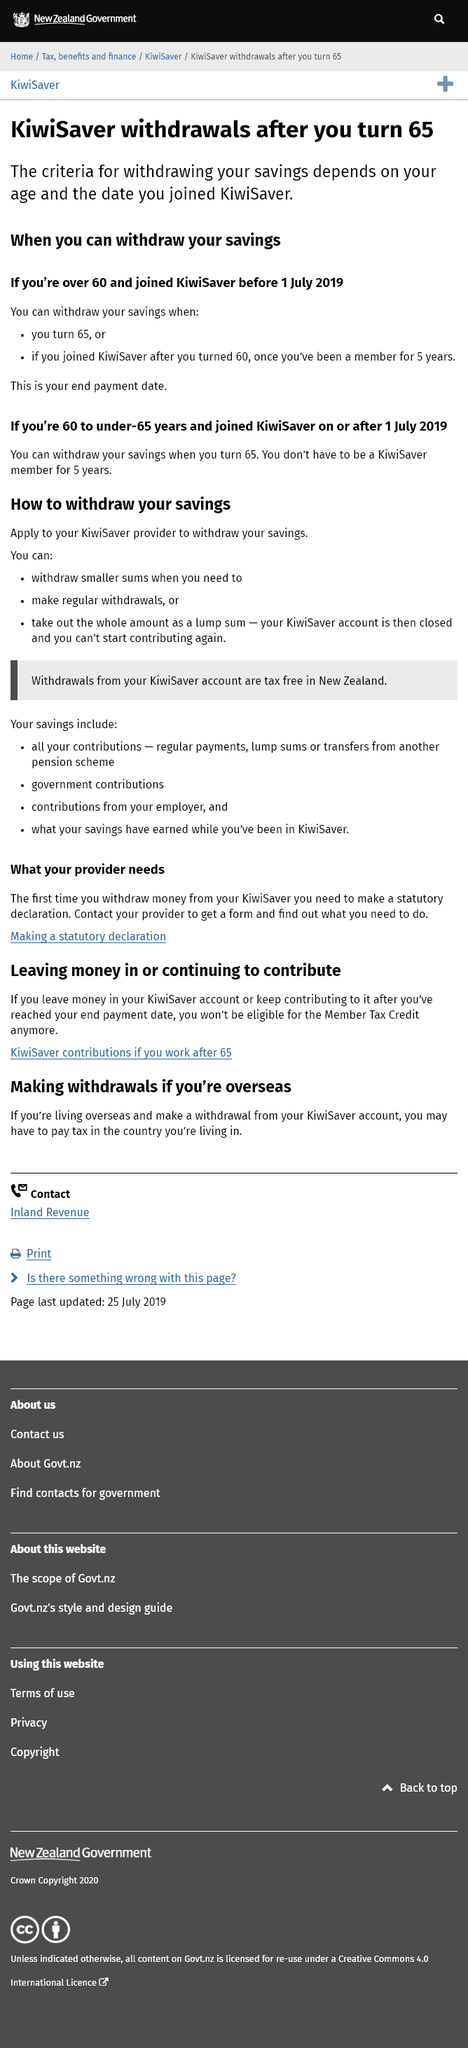Mention a couple of crucial points in this snapshot. Yes, you may have to pay tax in the country you're living in if you make a withdrawal from your KiwiSaver account while living overseas. Withdrawals from the KiwiSaver scheme in New Zealand are tax-free. The cut-off date of July 1, 2019, is stated as the date of significance for determining whether the Kiwisaver criteria apply to you, regardless of whether you opened the account before or after this date. To withdraw money from your KiwiSaver account for the first time, you must make a statutory declaration and provide it to your provider. You will not be eligible for the Member Tax Credit if you leave money in your KiwiSaver account. 